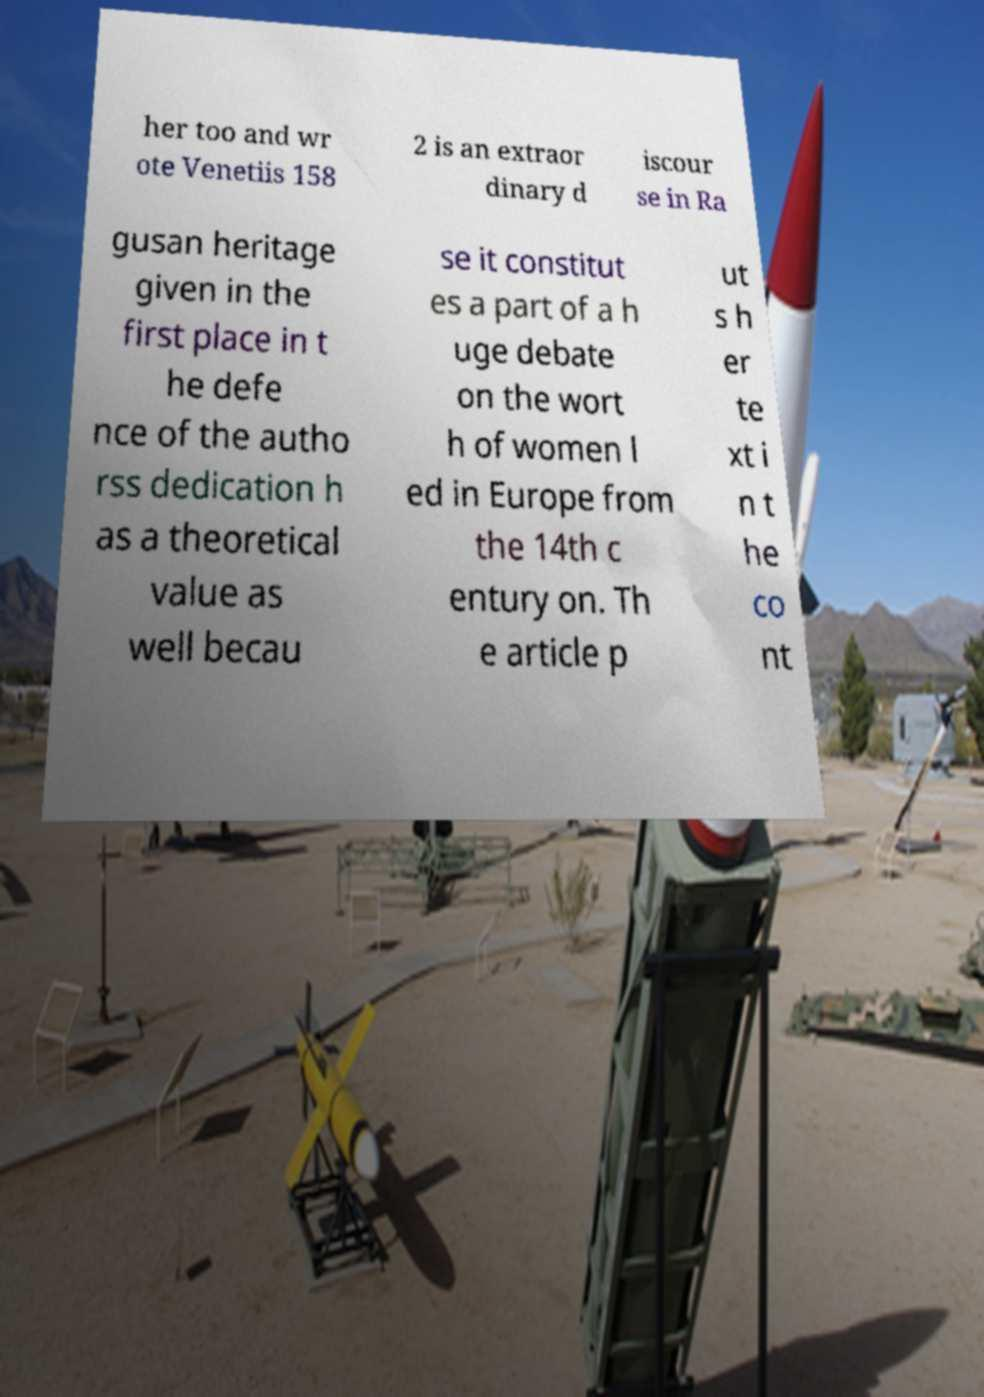Can you read and provide the text displayed in the image?This photo seems to have some interesting text. Can you extract and type it out for me? her too and wr ote Venetiis 158 2 is an extraor dinary d iscour se in Ra gusan heritage given in the first place in t he defe nce of the autho rss dedication h as a theoretical value as well becau se it constitut es a part of a h uge debate on the wort h of women l ed in Europe from the 14th c entury on. Th e article p ut s h er te xt i n t he co nt 